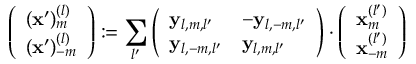Convert formula to latex. <formula><loc_0><loc_0><loc_500><loc_500>\left ( \begin{array} { l } { ( x ^ { \prime } ) _ { m } ^ { ( l ) } } \\ { ( x ^ { \prime } ) _ { - m } ^ { ( l ) } } \end{array} \right ) \colon = \sum _ { l ^ { \prime } } \left ( \begin{array} { l l } { y _ { l , m , l ^ { \prime } } } & { - y _ { l , - m , l ^ { \prime } } } \\ { y _ { l , - m , l ^ { \prime } } } & { y _ { l , m , l ^ { \prime } } } \end{array} \right ) \cdot \left ( \begin{array} { l } { x _ { m } ^ { ( l ^ { \prime } ) } } \\ { x _ { - m } ^ { ( l ^ { \prime } ) } } \end{array} \right )</formula> 